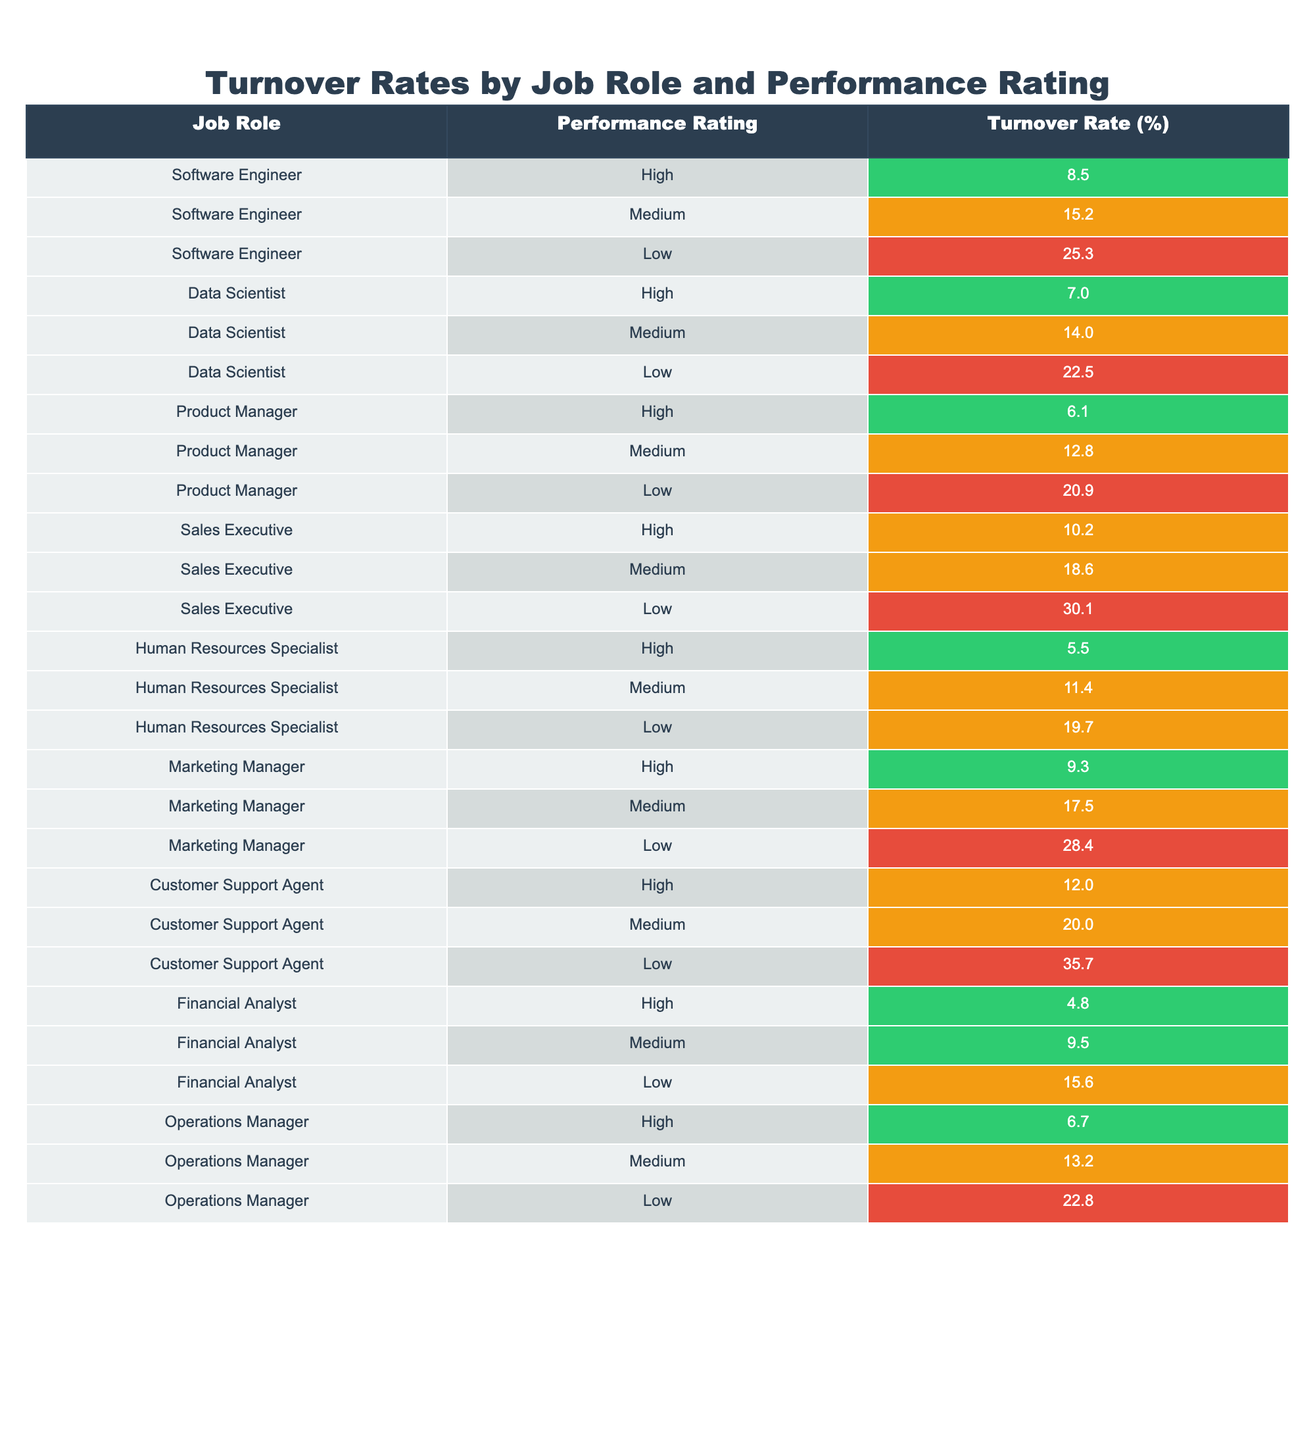What is the turnover rate for a High-performing Software Engineer? The table shows that the turnover rate for a High-performing Software Engineer is 8.5%.
Answer: 8.5% Which job role has the highest turnover rate among Low-performing employees? Looking at the Low-performance ratings, the Customer Support Agent has the highest turnover rate of 35.7%.
Answer: Customer Support Agent What is the average turnover rate for Medium-performing Data Scientists and Product Managers combined? The turnover rates for Medium-performing Data Scientists and Product Managers are 14.0% and 12.8%, respectively. Adding these gives 26.8%, and dividing by 2 gives an average of 13.4%.
Answer: 13.4% Is the turnover rate for High-performing Financial Analysts lower than the turnover rate for Medium-performing Human Resources Specialists? The turnover rate for High-performing Financial Analysts is 4.8%, while that for Medium-performing Human Resources Specialists is 11.4%. Since 4.8% is less than 11.4%, the statement is true.
Answer: Yes What is the difference in turnover rates between Medium-performing Sales Executives and Medium-performing Marketing Managers? The turnover rate for Medium-performing Sales Executives is 18.6%, while for Medium-performing Marketing Managers, it is 17.5%. The difference is 18.6% - 17.5% = 1.1%.
Answer: 1.1% Which job role, regardless of performance rating, has the lowest overall turnover rate? Scanning through all performance ratings, the Financial Analyst role has the lowest turnover rate at 4.8%.
Answer: Financial Analyst What is the total turnover rate for all High-performing job roles? The turnover rates for High-performing job roles are 8.5% + 7.0% + 6.1% + 10.2% + 5.5% + 9.3% + 12.0% + 4.8% + 6.7% = 69.1%. This total divided by the count (9) gives an average of 7.7%.
Answer: 69.1% Among the job roles, which has the largest gap between Low and High turnover rates? Evaluating the gaps: Software Engineer has a gap of 16.8% (25.3% - 8.5%), Sales Executive has a gap of 19.9% (30.1% - 10.2%), and Customer Support Agent has a gap of 23.7% (35.7% - 12.0%). The largest gap is in Customer Support Agent with 23.7%.
Answer: Customer Support Agent What percentage of Medium-performing Human Resources Specialists have higher turnover rates than Low-performing Data Scientists? The turnover rate for Medium-performing Human Resources Specialists is 11.4%, while for Low-performing Data Scientists, it is 22.5%. Therefore, none of the Medium-performing Human Resources Specialists have higher turnover rates than Low-performing Data Scientists.
Answer: 0% Which performance rating category has the highest overall turnover rate? By examining each performance rating category, we find that Low performers have the highest overall turnover rates compared to Medium and High performers.
Answer: Low performers 